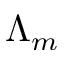Convert formula to latex. <formula><loc_0><loc_0><loc_500><loc_500>\Lambda _ { m }</formula> 